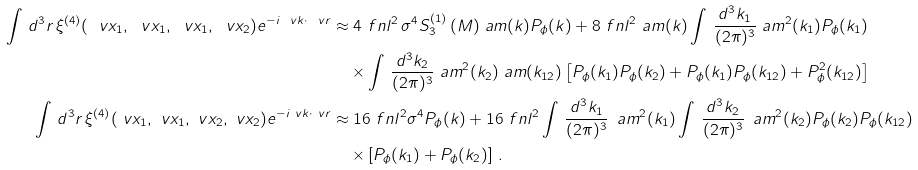Convert formula to latex. <formula><loc_0><loc_0><loc_500><loc_500>\int \, d ^ { 3 } r \, \xi ^ { ( 4 ) } ( \ v x _ { 1 } , \ v x _ { 1 } , \ v x _ { 1 } , \ v x _ { 2 } ) e ^ { - i \ v k \cdot \ v r } & \approx 4 \ f n l ^ { 2 } \, \sigma ^ { 4 } S _ { 3 } ^ { ( 1 ) } \, ( M ) \ a m ( k ) P _ { \phi } ( k ) + 8 \ f n l ^ { 2 } \ a m ( k ) \int \, \frac { d ^ { 3 } k _ { 1 } } { ( 2 \pi ) ^ { 3 } } \ a m ^ { 2 } ( k _ { 1 } ) P _ { \phi } ( k _ { 1 } ) \\ & \quad \times \int \, \frac { d ^ { 3 } k _ { 2 } } { ( 2 \pi ) ^ { 3 } } \ a m ^ { 2 } ( k _ { 2 } ) \ a m ( k _ { 1 2 } ) \left [ P _ { \phi } ( k _ { 1 } ) P _ { \phi } ( k _ { 2 } ) + P _ { \phi } ( k _ { 1 } ) P _ { \phi } ( k _ { 1 2 } ) + P _ { \phi } ^ { 2 } ( k _ { 1 2 } ) \right ] \\ \int \, d ^ { 3 } r \, \xi ^ { ( 4 ) } ( \ v x _ { 1 } , \ v x _ { 1 } , \ v x _ { 2 } , \ v x _ { 2 } ) e ^ { - i \ v k \cdot \ v r } & \approx 1 6 \ f n l ^ { 2 } \sigma ^ { 4 } P _ { \phi } ( k ) + 1 6 \ f n l ^ { 2 } \int \, \frac { d ^ { 3 } k _ { 1 } } { ( 2 \pi ) ^ { 3 } } \, \ a m ^ { 2 } ( k _ { 1 } ) \int \, \frac { d ^ { 3 } k _ { 2 } } { ( 2 \pi ) ^ { 3 } } \, \ a m ^ { 2 } ( k _ { 2 } ) P _ { \phi } ( k _ { 2 } ) P _ { \phi } ( k _ { 1 2 } ) \\ & \quad \times \left [ P _ { \phi } ( k _ { 1 } ) + P _ { \phi } ( k _ { 2 } ) \right ] \, .</formula> 